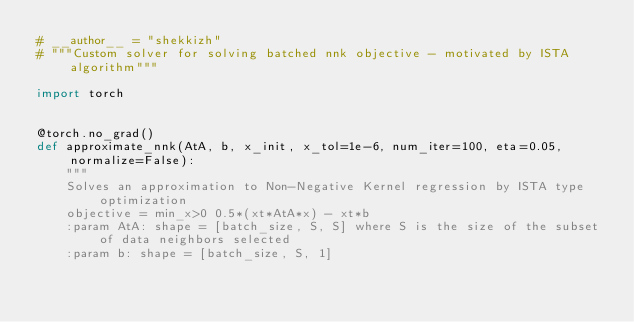Convert code to text. <code><loc_0><loc_0><loc_500><loc_500><_Python_># __author__ = "shekkizh"
# """Custom solver for solving batched nnk objective - motivated by ISTA algorithm"""

import torch


@torch.no_grad()
def approximate_nnk(AtA, b, x_init, x_tol=1e-6, num_iter=100, eta=0.05, normalize=False):
    """
    Solves an approximation to Non-Negative Kernel regression by ISTA type optimization
    objective = min_x>0 0.5*(xt*AtA*x) - xt*b
    :param AtA: shape = [batch_size, S, S] where S is the size of the subset of data neighbors selected
    :param b: shape = [batch_size, S, 1]</code> 